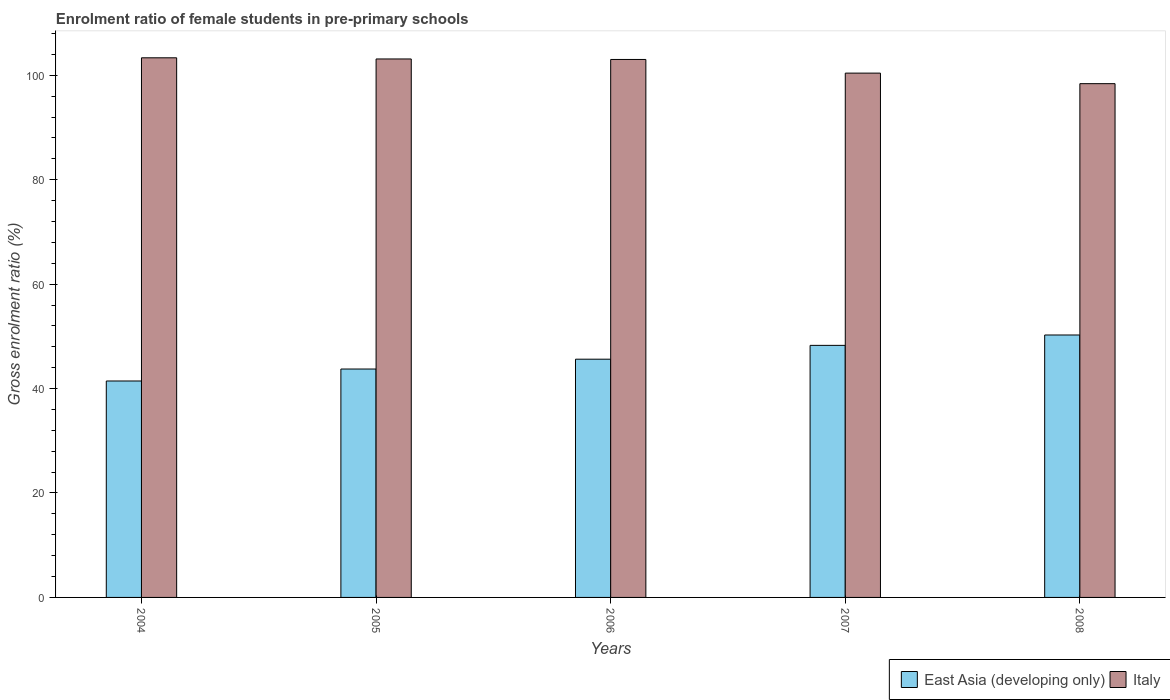Are the number of bars per tick equal to the number of legend labels?
Give a very brief answer. Yes. Are the number of bars on each tick of the X-axis equal?
Keep it short and to the point. Yes. What is the enrolment ratio of female students in pre-primary schools in East Asia (developing only) in 2004?
Your response must be concise. 41.45. Across all years, what is the maximum enrolment ratio of female students in pre-primary schools in Italy?
Your response must be concise. 103.34. Across all years, what is the minimum enrolment ratio of female students in pre-primary schools in Italy?
Your response must be concise. 98.39. In which year was the enrolment ratio of female students in pre-primary schools in Italy maximum?
Provide a succinct answer. 2004. What is the total enrolment ratio of female students in pre-primary schools in East Asia (developing only) in the graph?
Make the answer very short. 229.33. What is the difference between the enrolment ratio of female students in pre-primary schools in East Asia (developing only) in 2006 and that in 2008?
Ensure brevity in your answer.  -4.63. What is the difference between the enrolment ratio of female students in pre-primary schools in Italy in 2007 and the enrolment ratio of female students in pre-primary schools in East Asia (developing only) in 2004?
Offer a terse response. 58.96. What is the average enrolment ratio of female students in pre-primary schools in East Asia (developing only) per year?
Your response must be concise. 45.87. In the year 2008, what is the difference between the enrolment ratio of female students in pre-primary schools in East Asia (developing only) and enrolment ratio of female students in pre-primary schools in Italy?
Ensure brevity in your answer.  -48.13. In how many years, is the enrolment ratio of female students in pre-primary schools in Italy greater than 56 %?
Offer a very short reply. 5. What is the ratio of the enrolment ratio of female students in pre-primary schools in Italy in 2004 to that in 2008?
Your answer should be very brief. 1.05. What is the difference between the highest and the second highest enrolment ratio of female students in pre-primary schools in Italy?
Provide a succinct answer. 0.22. What is the difference between the highest and the lowest enrolment ratio of female students in pre-primary schools in Italy?
Your answer should be very brief. 4.95. What does the 2nd bar from the left in 2006 represents?
Offer a terse response. Italy. How many bars are there?
Provide a short and direct response. 10. Does the graph contain grids?
Your answer should be very brief. No. Where does the legend appear in the graph?
Keep it short and to the point. Bottom right. How many legend labels are there?
Your answer should be compact. 2. How are the legend labels stacked?
Your answer should be compact. Horizontal. What is the title of the graph?
Keep it short and to the point. Enrolment ratio of female students in pre-primary schools. What is the label or title of the X-axis?
Provide a short and direct response. Years. What is the Gross enrolment ratio (%) in East Asia (developing only) in 2004?
Your answer should be compact. 41.45. What is the Gross enrolment ratio (%) in Italy in 2004?
Give a very brief answer. 103.34. What is the Gross enrolment ratio (%) in East Asia (developing only) in 2005?
Your answer should be compact. 43.74. What is the Gross enrolment ratio (%) in Italy in 2005?
Keep it short and to the point. 103.12. What is the Gross enrolment ratio (%) of East Asia (developing only) in 2006?
Offer a very short reply. 45.62. What is the Gross enrolment ratio (%) in Italy in 2006?
Your answer should be compact. 103.02. What is the Gross enrolment ratio (%) in East Asia (developing only) in 2007?
Offer a terse response. 48.27. What is the Gross enrolment ratio (%) of Italy in 2007?
Your response must be concise. 100.41. What is the Gross enrolment ratio (%) of East Asia (developing only) in 2008?
Provide a short and direct response. 50.26. What is the Gross enrolment ratio (%) of Italy in 2008?
Your answer should be compact. 98.39. Across all years, what is the maximum Gross enrolment ratio (%) of East Asia (developing only)?
Make the answer very short. 50.26. Across all years, what is the maximum Gross enrolment ratio (%) of Italy?
Your answer should be very brief. 103.34. Across all years, what is the minimum Gross enrolment ratio (%) of East Asia (developing only)?
Provide a short and direct response. 41.45. Across all years, what is the minimum Gross enrolment ratio (%) of Italy?
Your answer should be compact. 98.39. What is the total Gross enrolment ratio (%) of East Asia (developing only) in the graph?
Provide a short and direct response. 229.33. What is the total Gross enrolment ratio (%) in Italy in the graph?
Your answer should be very brief. 508.27. What is the difference between the Gross enrolment ratio (%) in East Asia (developing only) in 2004 and that in 2005?
Make the answer very short. -2.29. What is the difference between the Gross enrolment ratio (%) of Italy in 2004 and that in 2005?
Keep it short and to the point. 0.22. What is the difference between the Gross enrolment ratio (%) of East Asia (developing only) in 2004 and that in 2006?
Keep it short and to the point. -4.18. What is the difference between the Gross enrolment ratio (%) in Italy in 2004 and that in 2006?
Provide a short and direct response. 0.32. What is the difference between the Gross enrolment ratio (%) of East Asia (developing only) in 2004 and that in 2007?
Your response must be concise. -6.82. What is the difference between the Gross enrolment ratio (%) in Italy in 2004 and that in 2007?
Make the answer very short. 2.93. What is the difference between the Gross enrolment ratio (%) in East Asia (developing only) in 2004 and that in 2008?
Make the answer very short. -8.81. What is the difference between the Gross enrolment ratio (%) in Italy in 2004 and that in 2008?
Offer a very short reply. 4.95. What is the difference between the Gross enrolment ratio (%) of East Asia (developing only) in 2005 and that in 2006?
Your answer should be very brief. -1.88. What is the difference between the Gross enrolment ratio (%) of Italy in 2005 and that in 2006?
Give a very brief answer. 0.1. What is the difference between the Gross enrolment ratio (%) of East Asia (developing only) in 2005 and that in 2007?
Your answer should be very brief. -4.53. What is the difference between the Gross enrolment ratio (%) of Italy in 2005 and that in 2007?
Offer a very short reply. 2.71. What is the difference between the Gross enrolment ratio (%) in East Asia (developing only) in 2005 and that in 2008?
Provide a succinct answer. -6.52. What is the difference between the Gross enrolment ratio (%) in Italy in 2005 and that in 2008?
Offer a very short reply. 4.73. What is the difference between the Gross enrolment ratio (%) in East Asia (developing only) in 2006 and that in 2007?
Provide a succinct answer. -2.65. What is the difference between the Gross enrolment ratio (%) of Italy in 2006 and that in 2007?
Offer a terse response. 2.62. What is the difference between the Gross enrolment ratio (%) in East Asia (developing only) in 2006 and that in 2008?
Ensure brevity in your answer.  -4.63. What is the difference between the Gross enrolment ratio (%) in Italy in 2006 and that in 2008?
Make the answer very short. 4.64. What is the difference between the Gross enrolment ratio (%) of East Asia (developing only) in 2007 and that in 2008?
Offer a very short reply. -1.99. What is the difference between the Gross enrolment ratio (%) in Italy in 2007 and that in 2008?
Ensure brevity in your answer.  2.02. What is the difference between the Gross enrolment ratio (%) in East Asia (developing only) in 2004 and the Gross enrolment ratio (%) in Italy in 2005?
Provide a short and direct response. -61.67. What is the difference between the Gross enrolment ratio (%) in East Asia (developing only) in 2004 and the Gross enrolment ratio (%) in Italy in 2006?
Your response must be concise. -61.57. What is the difference between the Gross enrolment ratio (%) in East Asia (developing only) in 2004 and the Gross enrolment ratio (%) in Italy in 2007?
Give a very brief answer. -58.96. What is the difference between the Gross enrolment ratio (%) in East Asia (developing only) in 2004 and the Gross enrolment ratio (%) in Italy in 2008?
Your answer should be compact. -56.94. What is the difference between the Gross enrolment ratio (%) of East Asia (developing only) in 2005 and the Gross enrolment ratio (%) of Italy in 2006?
Keep it short and to the point. -59.28. What is the difference between the Gross enrolment ratio (%) of East Asia (developing only) in 2005 and the Gross enrolment ratio (%) of Italy in 2007?
Give a very brief answer. -56.66. What is the difference between the Gross enrolment ratio (%) of East Asia (developing only) in 2005 and the Gross enrolment ratio (%) of Italy in 2008?
Your response must be concise. -54.65. What is the difference between the Gross enrolment ratio (%) in East Asia (developing only) in 2006 and the Gross enrolment ratio (%) in Italy in 2007?
Keep it short and to the point. -54.78. What is the difference between the Gross enrolment ratio (%) of East Asia (developing only) in 2006 and the Gross enrolment ratio (%) of Italy in 2008?
Offer a terse response. -52.76. What is the difference between the Gross enrolment ratio (%) of East Asia (developing only) in 2007 and the Gross enrolment ratio (%) of Italy in 2008?
Offer a very short reply. -50.12. What is the average Gross enrolment ratio (%) of East Asia (developing only) per year?
Make the answer very short. 45.87. What is the average Gross enrolment ratio (%) of Italy per year?
Your answer should be compact. 101.65. In the year 2004, what is the difference between the Gross enrolment ratio (%) of East Asia (developing only) and Gross enrolment ratio (%) of Italy?
Your answer should be very brief. -61.89. In the year 2005, what is the difference between the Gross enrolment ratio (%) of East Asia (developing only) and Gross enrolment ratio (%) of Italy?
Offer a very short reply. -59.38. In the year 2006, what is the difference between the Gross enrolment ratio (%) of East Asia (developing only) and Gross enrolment ratio (%) of Italy?
Your response must be concise. -57.4. In the year 2007, what is the difference between the Gross enrolment ratio (%) of East Asia (developing only) and Gross enrolment ratio (%) of Italy?
Give a very brief answer. -52.14. In the year 2008, what is the difference between the Gross enrolment ratio (%) in East Asia (developing only) and Gross enrolment ratio (%) in Italy?
Provide a succinct answer. -48.13. What is the ratio of the Gross enrolment ratio (%) of East Asia (developing only) in 2004 to that in 2005?
Your response must be concise. 0.95. What is the ratio of the Gross enrolment ratio (%) of East Asia (developing only) in 2004 to that in 2006?
Provide a succinct answer. 0.91. What is the ratio of the Gross enrolment ratio (%) of Italy in 2004 to that in 2006?
Offer a terse response. 1. What is the ratio of the Gross enrolment ratio (%) in East Asia (developing only) in 2004 to that in 2007?
Keep it short and to the point. 0.86. What is the ratio of the Gross enrolment ratio (%) in Italy in 2004 to that in 2007?
Provide a succinct answer. 1.03. What is the ratio of the Gross enrolment ratio (%) in East Asia (developing only) in 2004 to that in 2008?
Your answer should be very brief. 0.82. What is the ratio of the Gross enrolment ratio (%) in Italy in 2004 to that in 2008?
Your response must be concise. 1.05. What is the ratio of the Gross enrolment ratio (%) of East Asia (developing only) in 2005 to that in 2006?
Provide a succinct answer. 0.96. What is the ratio of the Gross enrolment ratio (%) in Italy in 2005 to that in 2006?
Offer a terse response. 1. What is the ratio of the Gross enrolment ratio (%) in East Asia (developing only) in 2005 to that in 2007?
Your answer should be compact. 0.91. What is the ratio of the Gross enrolment ratio (%) of East Asia (developing only) in 2005 to that in 2008?
Your response must be concise. 0.87. What is the ratio of the Gross enrolment ratio (%) in Italy in 2005 to that in 2008?
Your answer should be very brief. 1.05. What is the ratio of the Gross enrolment ratio (%) in East Asia (developing only) in 2006 to that in 2007?
Offer a terse response. 0.95. What is the ratio of the Gross enrolment ratio (%) of Italy in 2006 to that in 2007?
Give a very brief answer. 1.03. What is the ratio of the Gross enrolment ratio (%) of East Asia (developing only) in 2006 to that in 2008?
Keep it short and to the point. 0.91. What is the ratio of the Gross enrolment ratio (%) in Italy in 2006 to that in 2008?
Your answer should be very brief. 1.05. What is the ratio of the Gross enrolment ratio (%) of East Asia (developing only) in 2007 to that in 2008?
Provide a succinct answer. 0.96. What is the ratio of the Gross enrolment ratio (%) in Italy in 2007 to that in 2008?
Provide a short and direct response. 1.02. What is the difference between the highest and the second highest Gross enrolment ratio (%) of East Asia (developing only)?
Provide a short and direct response. 1.99. What is the difference between the highest and the second highest Gross enrolment ratio (%) in Italy?
Ensure brevity in your answer.  0.22. What is the difference between the highest and the lowest Gross enrolment ratio (%) of East Asia (developing only)?
Ensure brevity in your answer.  8.81. What is the difference between the highest and the lowest Gross enrolment ratio (%) in Italy?
Keep it short and to the point. 4.95. 